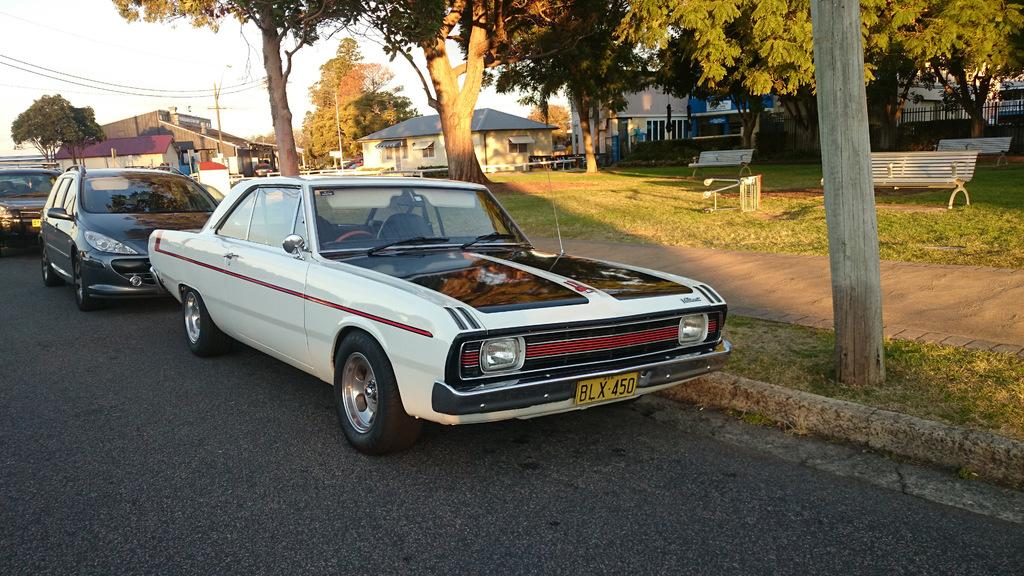What type of vehicles can be seen on the road in the image? There are cars on the road in the image. What type of vegetation is visible in the image? There is grass visible in the image. What type of seating is present in the image? There are benches in the image. What type of structures can be seen in the background of the image? Houses are present in the background of the image. What other natural elements can be seen in the background of the image? Trees are visible in the background of the image. What type of man-made structures can be seen in the background of the image? Poles are present in the background of the image. What type of utility infrastructure can be seen in the background of the image? Wires are visible in the background of the image. What part of the natural environment is visible in the background of the image? The sky is visible in the background of the image. What type of basin is visible in the image? There is no basin present in the image. What type of cooking activity is taking place in the image? There is no cooking activity present in the image. What type of headwear is visible on the people in the image? There are no people visible in the image, so no headwear can be observed. 